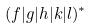<formula> <loc_0><loc_0><loc_500><loc_500>( f | g | h | k | l ) ^ { * }</formula> 